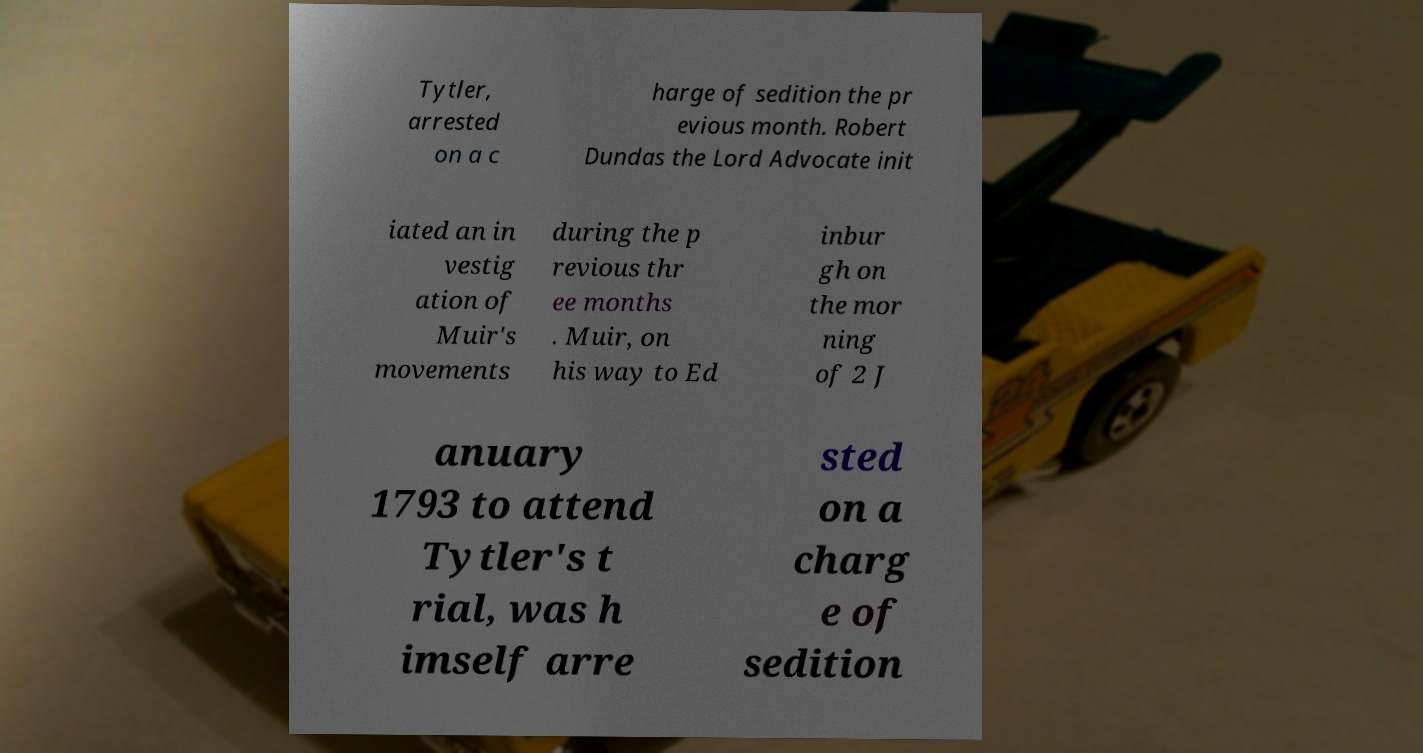Please read and relay the text visible in this image. What does it say? Tytler, arrested on a c harge of sedition the pr evious month. Robert Dundas the Lord Advocate init iated an in vestig ation of Muir's movements during the p revious thr ee months . Muir, on his way to Ed inbur gh on the mor ning of 2 J anuary 1793 to attend Tytler's t rial, was h imself arre sted on a charg e of sedition 